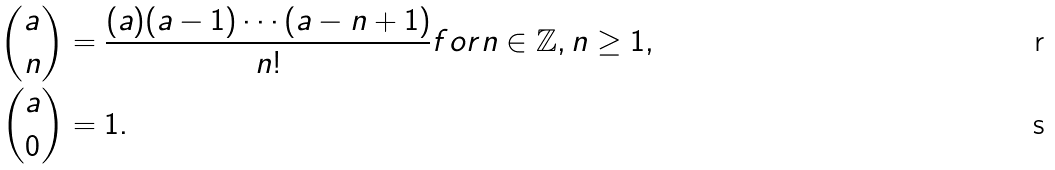<formula> <loc_0><loc_0><loc_500><loc_500>\binom { a } { n } & = \frac { ( a ) ( a - 1 ) \cdots ( a - n + 1 ) } { n ! } f o r n \in \mathbb { Z } , n \geq 1 , \\ \binom { a } { 0 } & = 1 .</formula> 